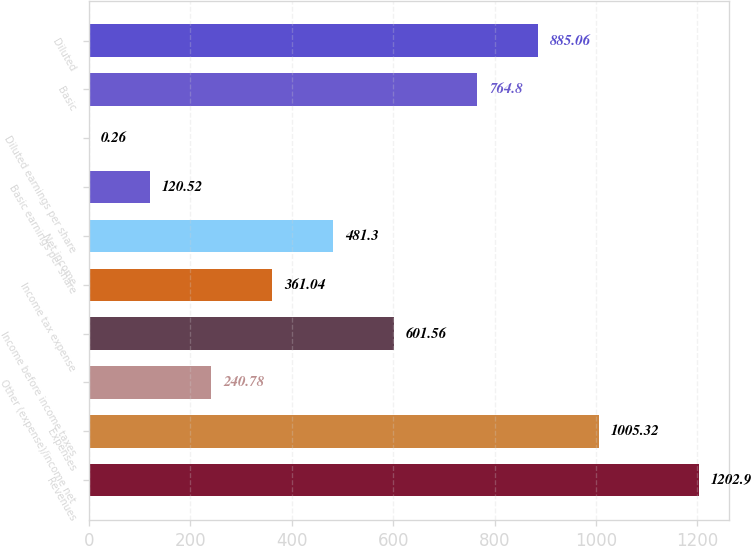<chart> <loc_0><loc_0><loc_500><loc_500><bar_chart><fcel>Revenues<fcel>Expenses<fcel>Other (expense)/income net<fcel>Income before income taxes<fcel>Income tax expense<fcel>Net income<fcel>Basic earnings per share<fcel>Diluted earnings per share<fcel>Basic<fcel>Diluted<nl><fcel>1202.9<fcel>1005.32<fcel>240.78<fcel>601.56<fcel>361.04<fcel>481.3<fcel>120.52<fcel>0.26<fcel>764.8<fcel>885.06<nl></chart> 